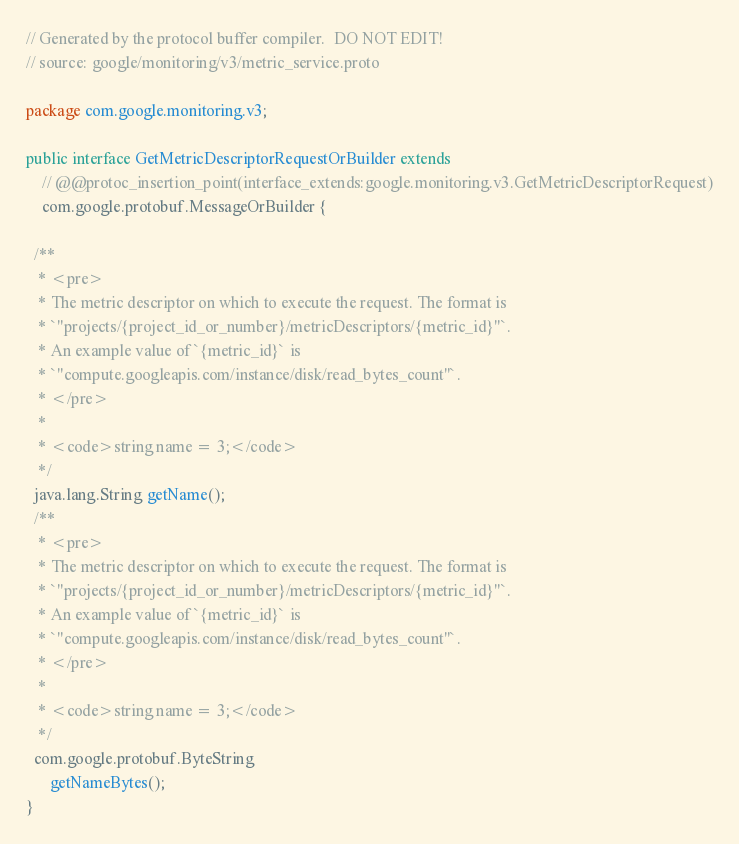<code> <loc_0><loc_0><loc_500><loc_500><_Java_>// Generated by the protocol buffer compiler.  DO NOT EDIT!
// source: google/monitoring/v3/metric_service.proto

package com.google.monitoring.v3;

public interface GetMetricDescriptorRequestOrBuilder extends
    // @@protoc_insertion_point(interface_extends:google.monitoring.v3.GetMetricDescriptorRequest)
    com.google.protobuf.MessageOrBuilder {

  /**
   * <pre>
   * The metric descriptor on which to execute the request. The format is
   * `"projects/{project_id_or_number}/metricDescriptors/{metric_id}"`.
   * An example value of `{metric_id}` is
   * `"compute.googleapis.com/instance/disk/read_bytes_count"`.
   * </pre>
   *
   * <code>string name = 3;</code>
   */
  java.lang.String getName();
  /**
   * <pre>
   * The metric descriptor on which to execute the request. The format is
   * `"projects/{project_id_or_number}/metricDescriptors/{metric_id}"`.
   * An example value of `{metric_id}` is
   * `"compute.googleapis.com/instance/disk/read_bytes_count"`.
   * </pre>
   *
   * <code>string name = 3;</code>
   */
  com.google.protobuf.ByteString
      getNameBytes();
}
</code> 